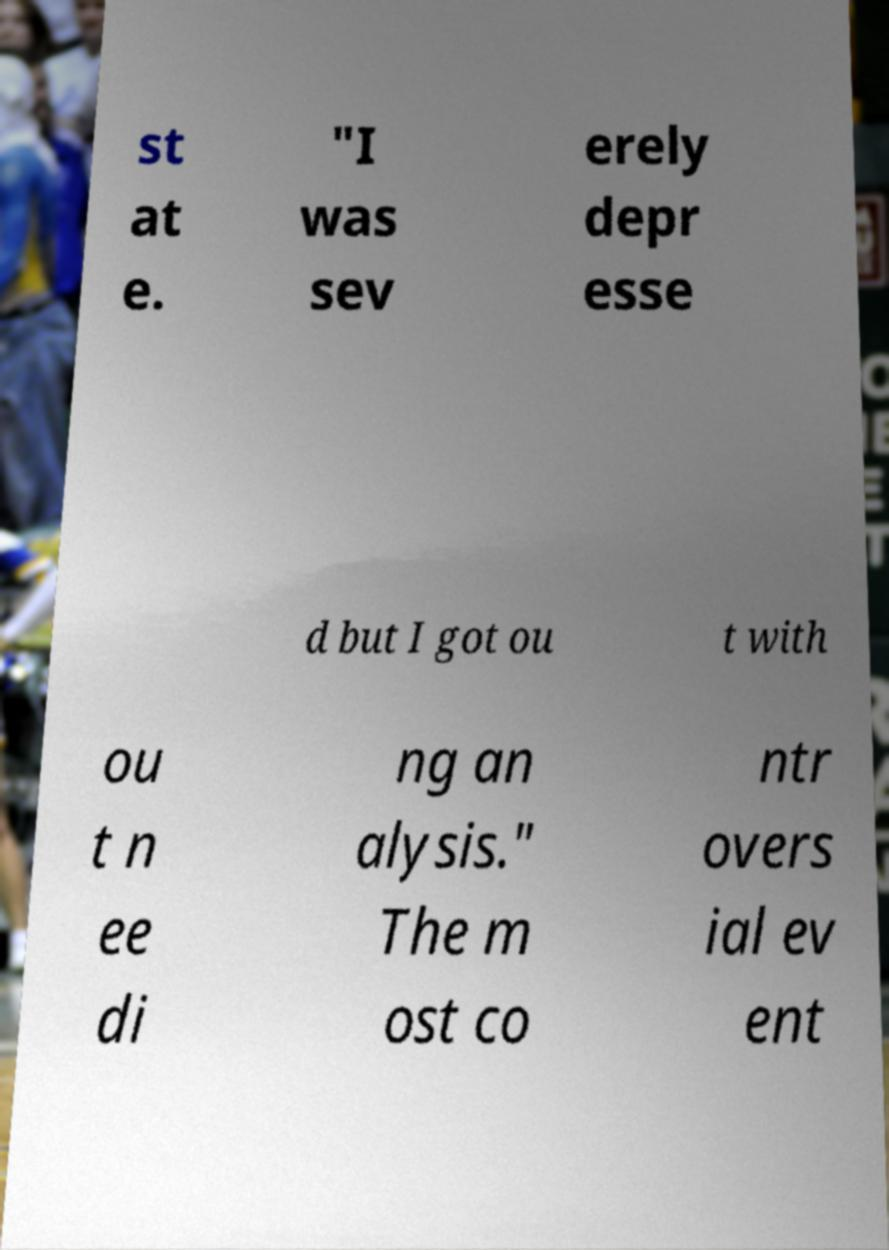I need the written content from this picture converted into text. Can you do that? st at e. "I was sev erely depr esse d but I got ou t with ou t n ee di ng an alysis." The m ost co ntr overs ial ev ent 